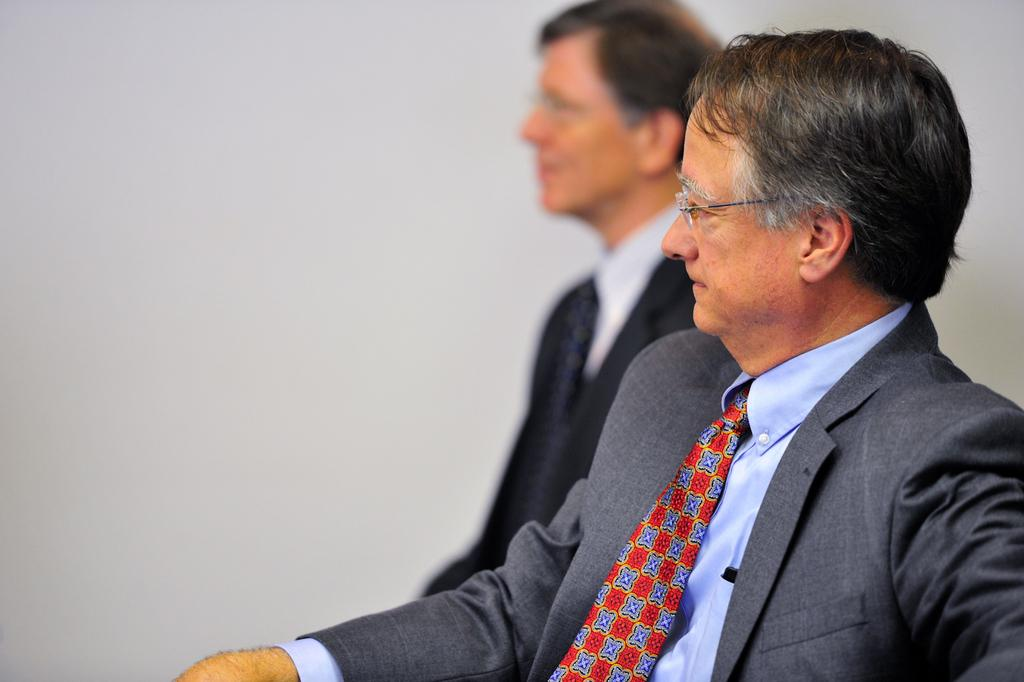How many people are in the image? There are two people in the image. What is one of the men wearing? One of the men is wearing a tie. What else can be observed about the man wearing a tie? The man with the tie is wearing spectacles. What is the color of the background in the image? The background of the image is white. Can you hear any thunder in the image? There is no sound present in the image, so it is not possible to hear any thunder. 